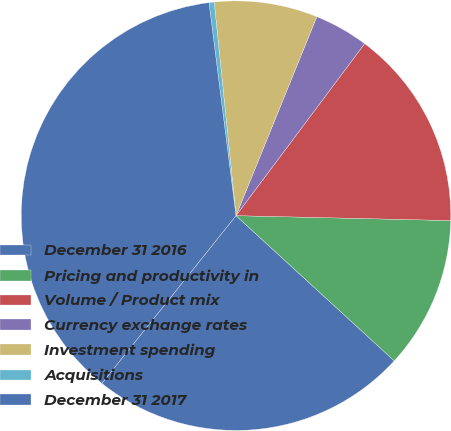Convert chart to OTSL. <chart><loc_0><loc_0><loc_500><loc_500><pie_chart><fcel>December 31 2016<fcel>Pricing and productivity in<fcel>Volume / Product mix<fcel>Currency exchange rates<fcel>Investment spending<fcel>Acquisitions<fcel>December 31 2017<nl><fcel>23.92%<fcel>11.45%<fcel>15.14%<fcel>4.08%<fcel>7.76%<fcel>0.39%<fcel>37.25%<nl></chart> 